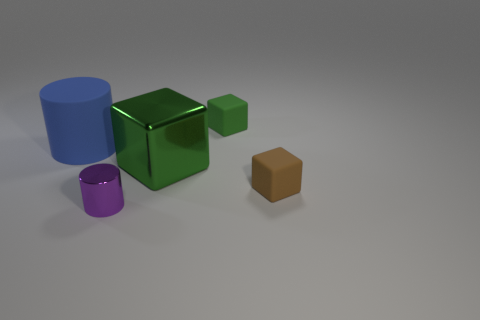There is another block that is the same color as the large metal cube; what is its size?
Your answer should be very brief. Small. What number of tiny things are green metal objects or gray balls?
Give a very brief answer. 0. Is there anything else that has the same color as the large shiny object?
Your answer should be compact. Yes. The small cube in front of the green cube to the left of the matte cube that is behind the large metallic object is made of what material?
Keep it short and to the point. Rubber. How many matte things are either large green things or blocks?
Make the answer very short. 2. How many blue objects are cylinders or big metal cylinders?
Ensure brevity in your answer.  1. There is a large thing right of the small purple metal cylinder; is its color the same as the metal cylinder?
Ensure brevity in your answer.  No. Are the brown thing and the tiny green cube made of the same material?
Your answer should be very brief. Yes. Is the number of small purple objects that are behind the large metallic thing the same as the number of brown matte objects that are in front of the tiny purple thing?
Offer a very short reply. Yes. What material is the tiny purple thing that is the same shape as the blue matte thing?
Make the answer very short. Metal. 